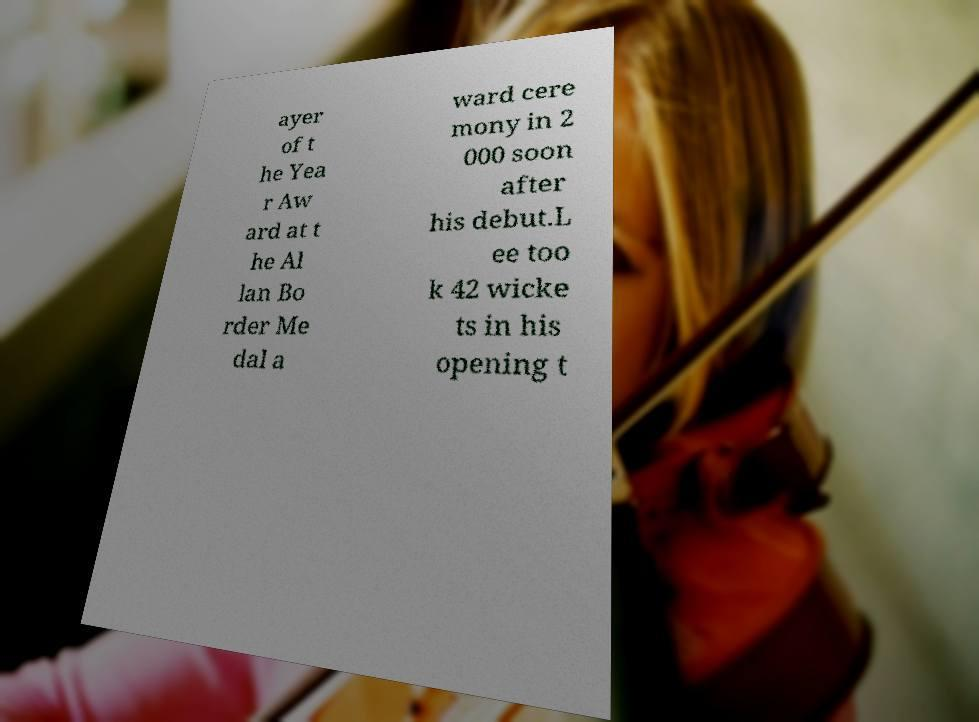Could you extract and type out the text from this image? ayer of t he Yea r Aw ard at t he Al lan Bo rder Me dal a ward cere mony in 2 000 soon after his debut.L ee too k 42 wicke ts in his opening t 